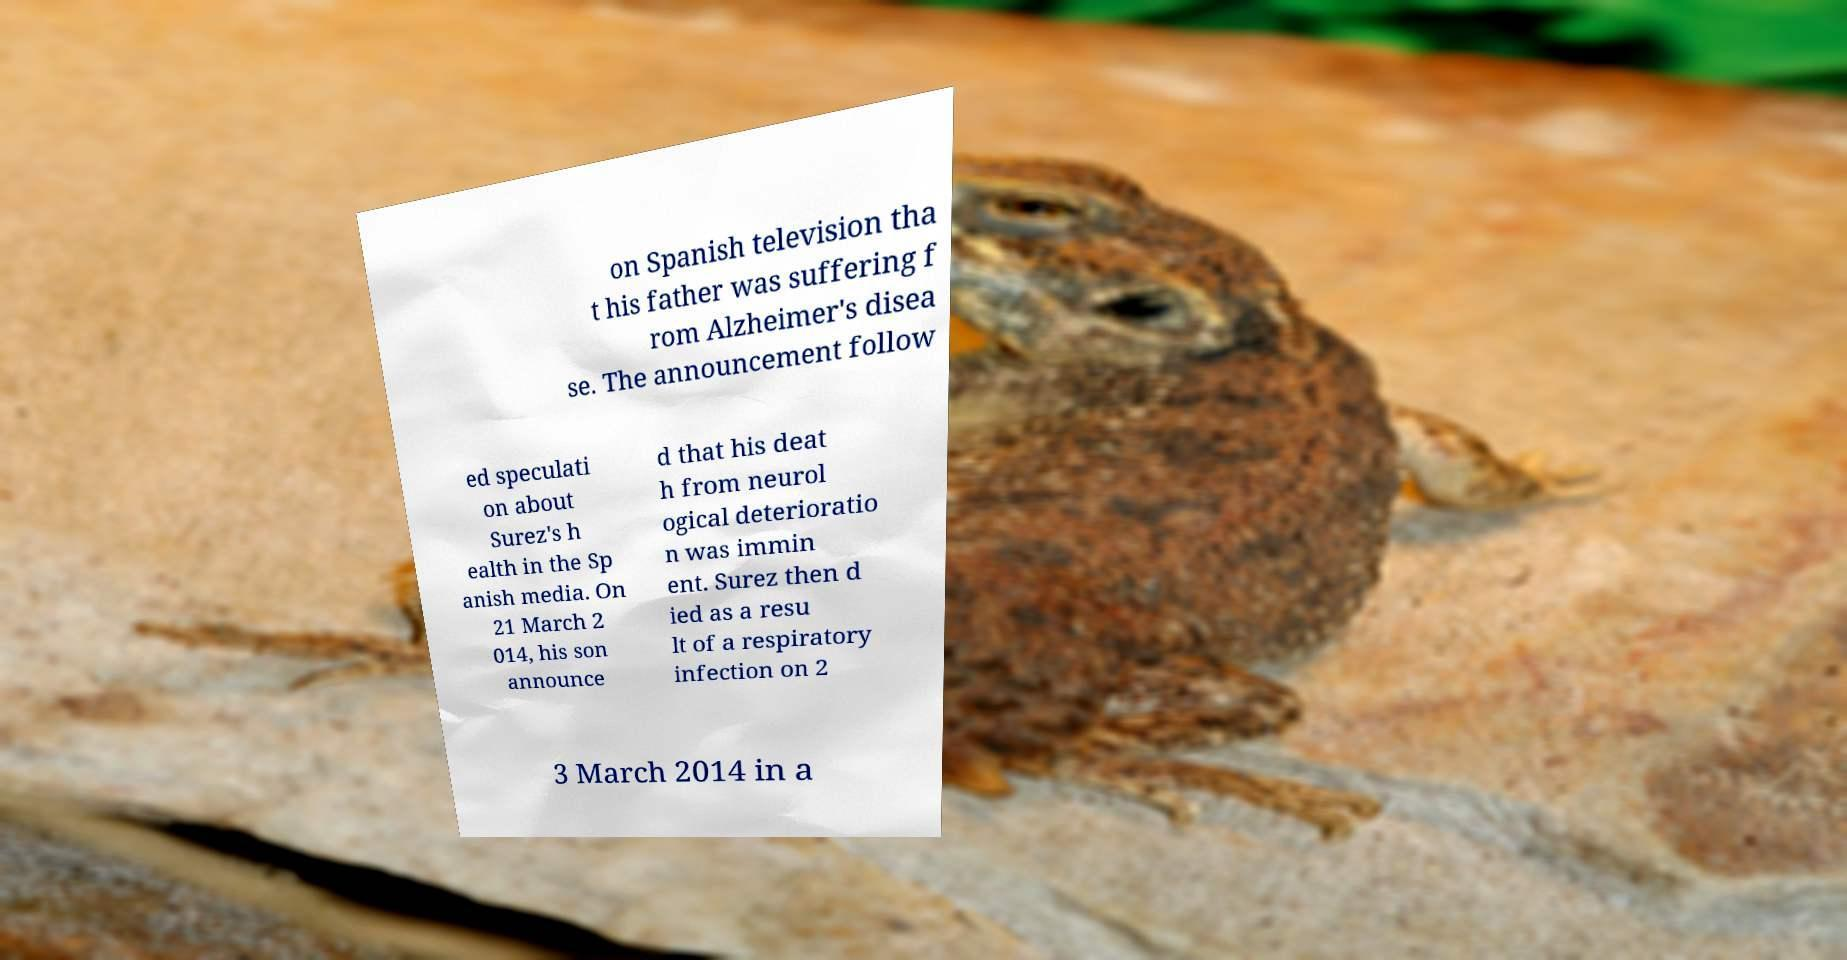What messages or text are displayed in this image? I need them in a readable, typed format. on Spanish television tha t his father was suffering f rom Alzheimer's disea se. The announcement follow ed speculati on about Surez's h ealth in the Sp anish media. On 21 March 2 014, his son announce d that his deat h from neurol ogical deterioratio n was immin ent. Surez then d ied as a resu lt of a respiratory infection on 2 3 March 2014 in a 